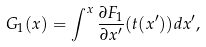<formula> <loc_0><loc_0><loc_500><loc_500>G _ { 1 } ( x ) = \int ^ { x } \frac { \partial F _ { 1 } } { \partial x ^ { \prime } } ( t ( x ^ { \prime } ) ) d x ^ { \prime } ,</formula> 